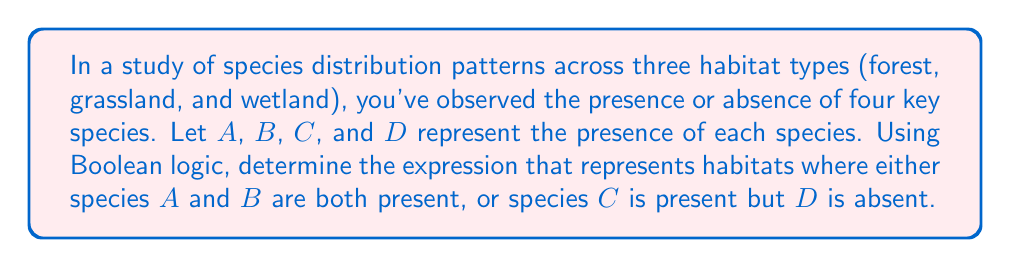Help me with this question. Let's approach this step-by-step using Boolean algebra:

1) First, let's define our Boolean variables:
   A = Species A is present
   B = Species B is present
   C = Species C is present
   D = Species D is present

2) We need to represent two conditions:
   Condition 1: Species A and B are both present
   Condition 2: Species C is present but D is absent

3) For Condition 1:
   Species A and B both present = $A \wedge B$

4) For Condition 2:
   Species C present = $C$
   Species D absent = $\neg D$
   Combined: $C \wedge \neg D$

5) We need habitats where either Condition 1 OR Condition 2 is true:
   $(A \wedge B) \vee (C \wedge \neg D)$

6) This expression represents the Boolean logic for habitats meeting our criteria.

7) In environmental research, this could be used to identify habitats of interest for conservation efforts or to study interactions between species.
Answer: $(A \wedge B) \vee (C \wedge \neg D)$ 